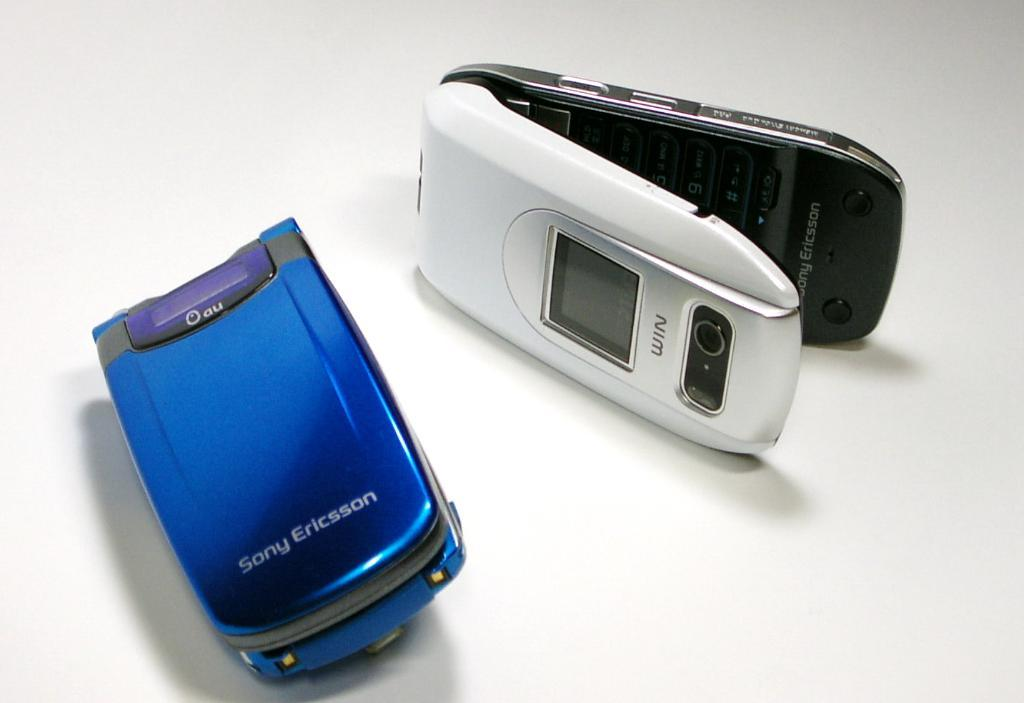<image>
Summarize the visual content of the image. Two Sony Ericsson flip phones, one blue and one white. 